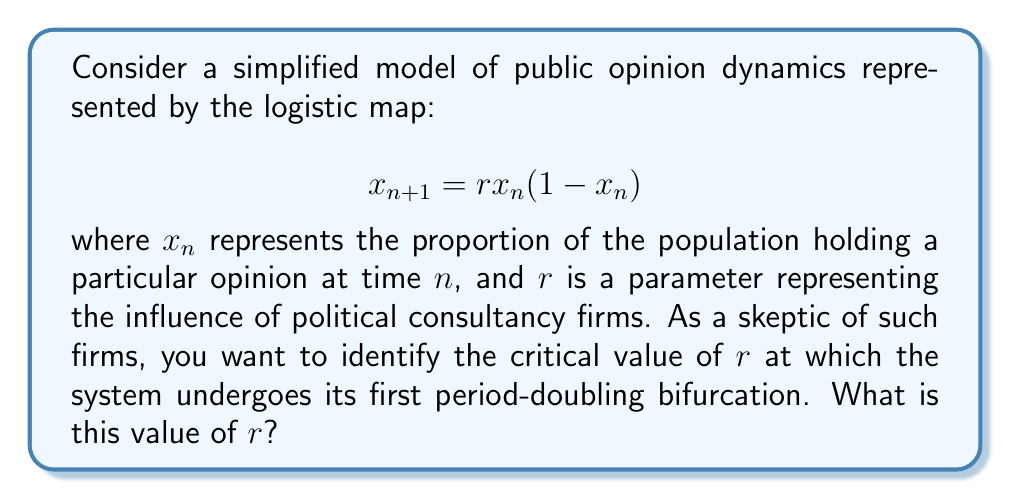Give your solution to this math problem. To find the first period-doubling bifurcation point in the logistic map, we need to follow these steps:

1) The fixed points of the logistic map are given by solving:
   $$x = rx(1-x)$$

2) This yields two fixed points: $x=0$ and $x=1-\frac{1}{r}$

3) The stability of the non-zero fixed point changes when:
   $$\left|\frac{d}{dx}(rx(1-x))\right|_{x=1-\frac{1}{r}} = 1$$

4) Calculating the derivative:
   $$\frac{d}{dx}(rx(1-x)) = r(1-2x)$$

5) Evaluating at the non-zero fixed point:
   $$\left|r(1-2(1-\frac{1}{r}))\right| = 1$$

6) Simplifying:
   $$\left|r(1-2+\frac{2}{r})\right| = 1$$
   $$\left|-r+2\right| = 1$$

7) Solving this equation:
   $-r+2 = 1$ or $-r+2 = -1$
   $r = 1$ or $r = 3$

8) The first period-doubling bifurcation occurs at the larger value, $r = 3$.

This critical value represents the point at which the system transitions from a stable fixed point to an oscillation between two values, indicating a significant change in the dynamics of public opinion.
Answer: $r = 3$ 